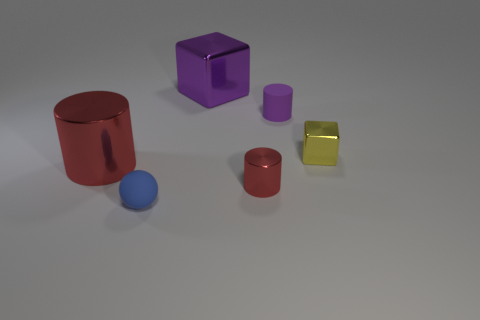Do the shiny cylinder left of the blue object and the small purple cylinder have the same size?
Offer a very short reply. No. There is a block behind the yellow thing that is in front of the purple rubber cylinder; how big is it?
Make the answer very short. Large. There is a yellow object that is the same material as the large cylinder; what shape is it?
Make the answer very short. Cube. Does the purple shiny thing have the same shape as the small shiny object that is to the right of the small purple rubber cylinder?
Give a very brief answer. Yes. What is the material of the small cylinder that is behind the shiny cylinder left of the small metallic cylinder?
Keep it short and to the point. Rubber. How many other things are there of the same shape as the tiny purple matte object?
Offer a terse response. 2. There is a object that is behind the purple matte object; is it the same shape as the tiny metal object on the right side of the small red shiny cylinder?
Your answer should be compact. Yes. What is the material of the tiny purple cylinder?
Offer a terse response. Rubber. There is a blue ball to the left of the small shiny cylinder; what is it made of?
Your response must be concise. Rubber. Is there anything else of the same color as the rubber ball?
Offer a terse response. No. 